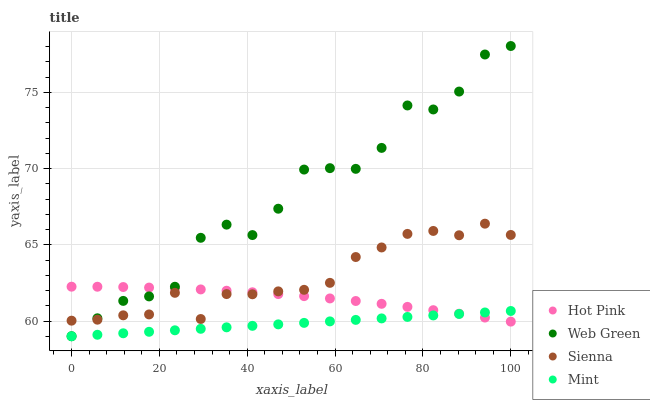Does Mint have the minimum area under the curve?
Answer yes or no. Yes. Does Web Green have the maximum area under the curve?
Answer yes or no. Yes. Does Hot Pink have the minimum area under the curve?
Answer yes or no. No. Does Hot Pink have the maximum area under the curve?
Answer yes or no. No. Is Mint the smoothest?
Answer yes or no. Yes. Is Web Green the roughest?
Answer yes or no. Yes. Is Hot Pink the smoothest?
Answer yes or no. No. Is Hot Pink the roughest?
Answer yes or no. No. Does Mint have the lowest value?
Answer yes or no. Yes. Does Hot Pink have the lowest value?
Answer yes or no. No. Does Web Green have the highest value?
Answer yes or no. Yes. Does Hot Pink have the highest value?
Answer yes or no. No. Is Mint less than Sienna?
Answer yes or no. Yes. Is Sienna greater than Mint?
Answer yes or no. Yes. Does Hot Pink intersect Web Green?
Answer yes or no. Yes. Is Hot Pink less than Web Green?
Answer yes or no. No. Is Hot Pink greater than Web Green?
Answer yes or no. No. Does Mint intersect Sienna?
Answer yes or no. No. 